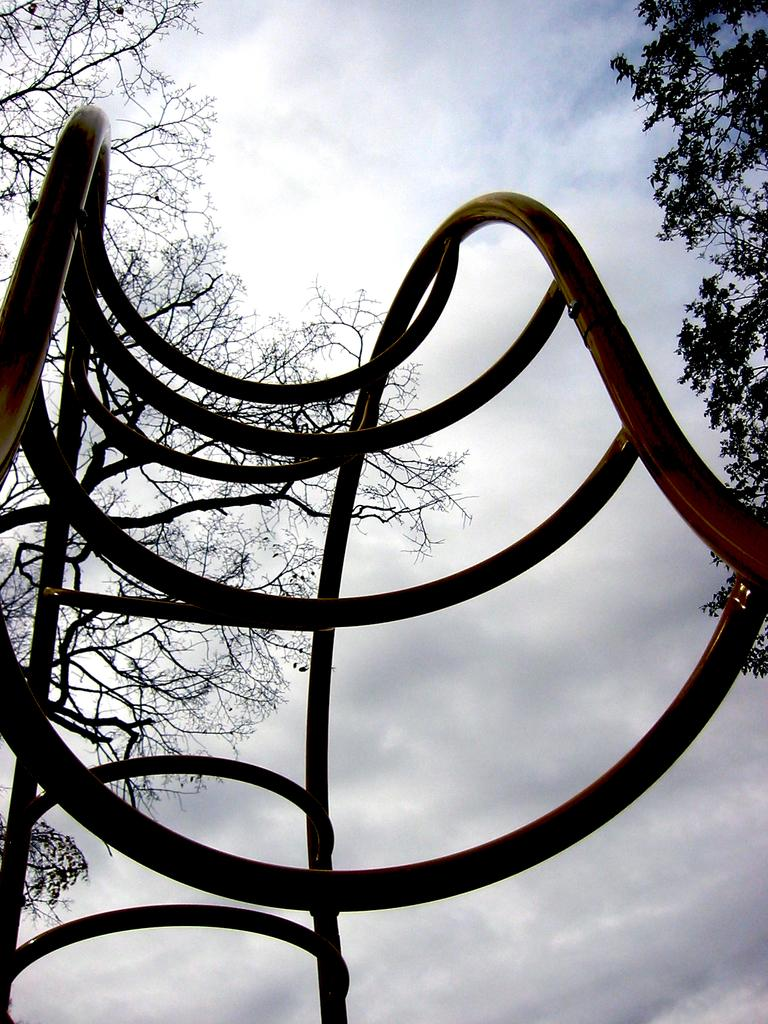What objects are located in the middle of the image? There are metal rods in the middle of the image. What type of natural elements can be seen in the background of the image? There are trees in the background of the image. What is visible in the sky in the background of the image? The sky is visible in the background of the image, and clouds are present. Can you see a snail climbing up the metal rods in the image? No, there is no snail present in the image. 